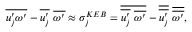Convert formula to latex. <formula><loc_0><loc_0><loc_500><loc_500>\overline { { u _ { j } ^ { \prime } \omega ^ { \prime } } } - \overline { { u _ { j } ^ { \prime } } } \overline { { \omega ^ { \prime } } } \approx \sigma _ { j } ^ { K E B } = \overline { { \overline { { u _ { j } ^ { \prime } } } \overline { { \omega ^ { \prime } } } } } - \overline { { \overline { { u _ { j } ^ { \prime } } } } } \overline { { \overline { { \omega ^ { \prime } } } } } ,</formula> 